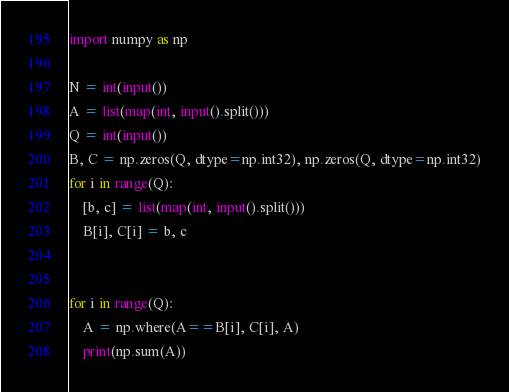Convert code to text. <code><loc_0><loc_0><loc_500><loc_500><_Python_>import numpy as np

N = int(input())
A = list(map(int, input().split()))
Q = int(input())
B, C = np.zeros(Q, dtype=np.int32), np.zeros(Q, dtype=np.int32)
for i in range(Q):
    [b, c] = list(map(int, input().split()))
    B[i], C[i] = b, c


for i in range(Q):
    A = np.where(A==B[i], C[i], A)
    print(np.sum(A))
</code> 